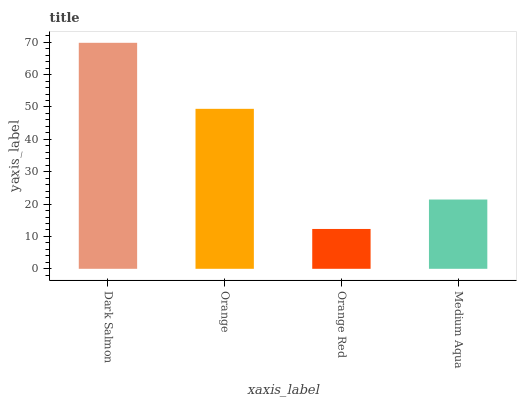Is Orange Red the minimum?
Answer yes or no. Yes. Is Dark Salmon the maximum?
Answer yes or no. Yes. Is Orange the minimum?
Answer yes or no. No. Is Orange the maximum?
Answer yes or no. No. Is Dark Salmon greater than Orange?
Answer yes or no. Yes. Is Orange less than Dark Salmon?
Answer yes or no. Yes. Is Orange greater than Dark Salmon?
Answer yes or no. No. Is Dark Salmon less than Orange?
Answer yes or no. No. Is Orange the high median?
Answer yes or no. Yes. Is Medium Aqua the low median?
Answer yes or no. Yes. Is Medium Aqua the high median?
Answer yes or no. No. Is Dark Salmon the low median?
Answer yes or no. No. 